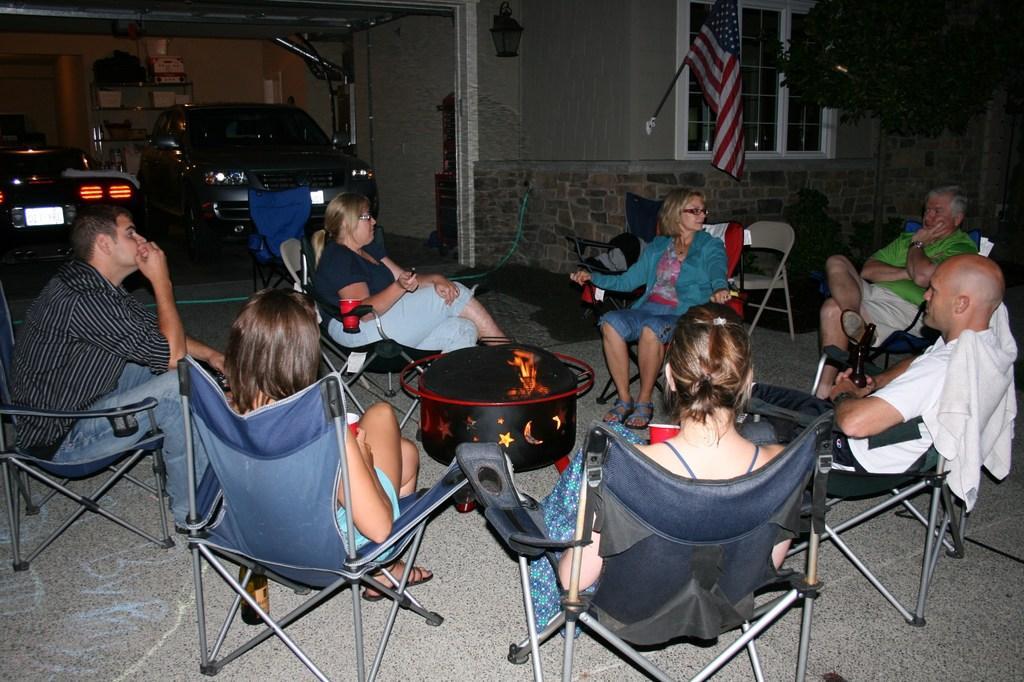Can you describe this image briefly? There are group of people sitting around a black box which has fire in it and there are cars,a flag and a building in the background. 